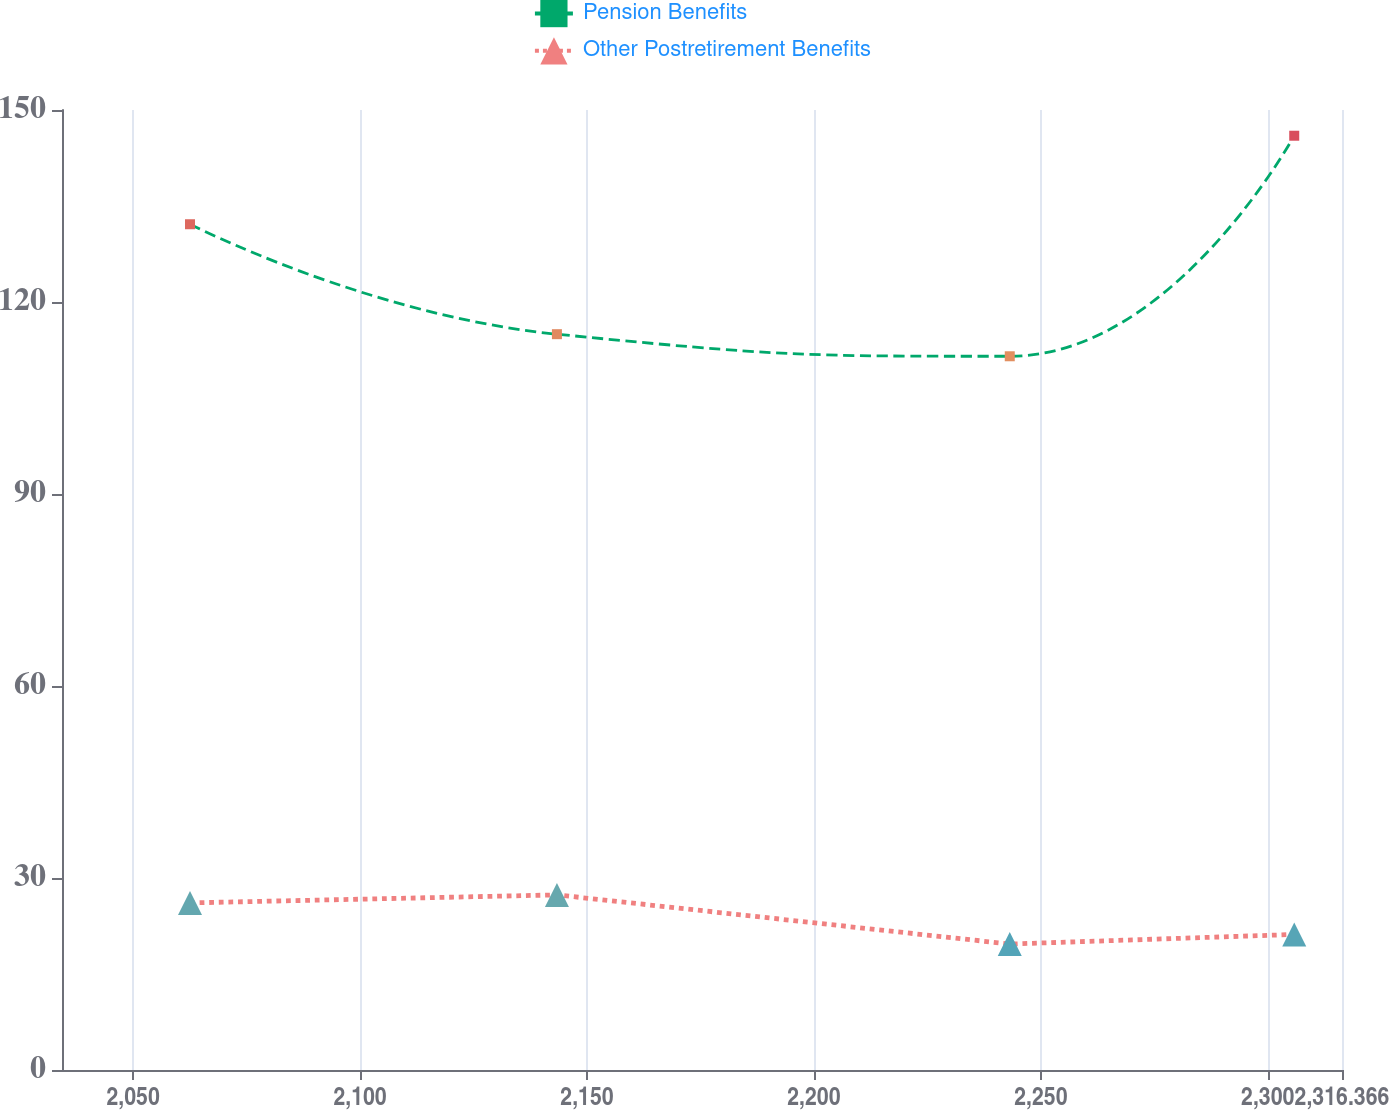<chart> <loc_0><loc_0><loc_500><loc_500><line_chart><ecel><fcel>Pension Benefits<fcel>Other Postretirement Benefits<nl><fcel>2062.53<fcel>132.15<fcel>26.11<nl><fcel>2143.38<fcel>114.97<fcel>27.36<nl><fcel>2243.16<fcel>111.52<fcel>19.68<nl><fcel>2305.84<fcel>145.98<fcel>21.18<nl><fcel>2344.57<fcel>118.42<fcel>18.31<nl></chart> 